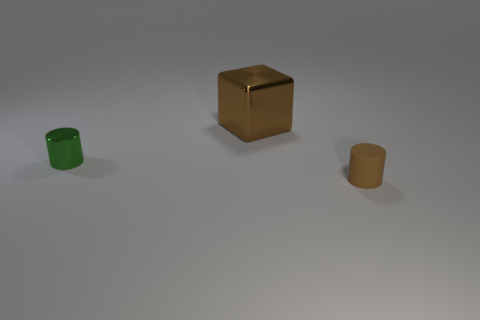The big metal object that is the same color as the tiny matte object is what shape?
Ensure brevity in your answer.  Cube. There is a cylinder left of the brown cube; what is its size?
Keep it short and to the point. Small. There is a brown object that is made of the same material as the green cylinder; what shape is it?
Ensure brevity in your answer.  Cube. Is the green thing made of the same material as the cylinder on the right side of the green object?
Offer a terse response. No. There is a small thing in front of the green shiny cylinder; does it have the same shape as the large brown shiny object?
Keep it short and to the point. No. There is a green object that is the same shape as the brown rubber thing; what is it made of?
Give a very brief answer. Metal. There is a rubber object; is its shape the same as the brown thing that is behind the tiny brown cylinder?
Your answer should be compact. No. What is the color of the object that is right of the tiny shiny object and in front of the large metal block?
Give a very brief answer. Brown. Are there any brown balls?
Offer a terse response. No. Are there the same number of big objects on the left side of the small green object and blue rubber objects?
Provide a short and direct response. Yes. 